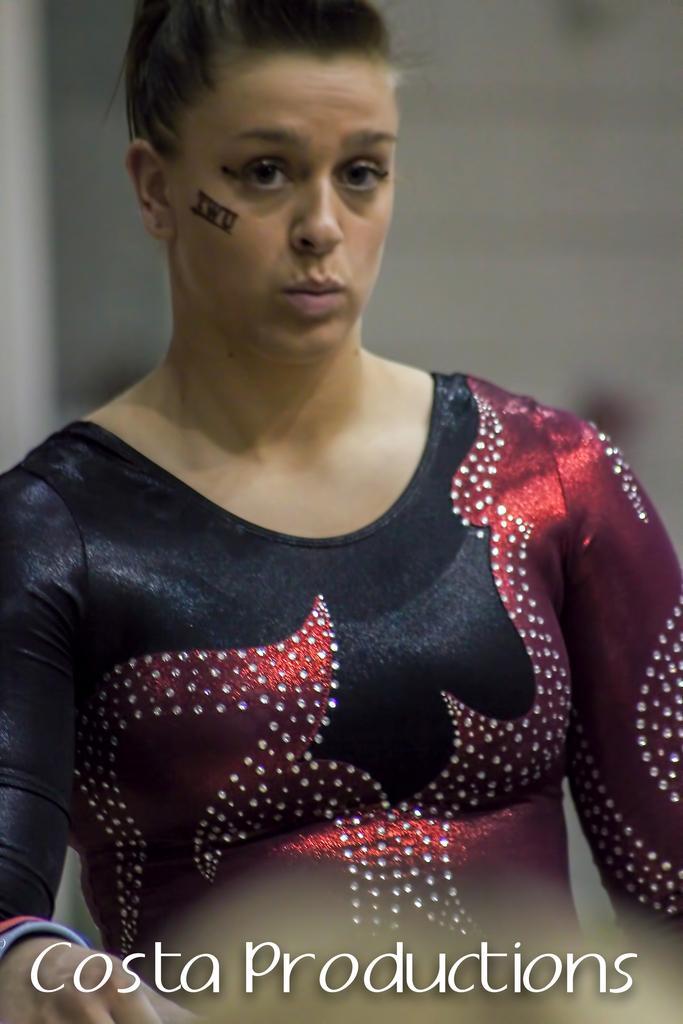Describe this image in one or two sentences. In this image, we can see a woman in black and maroon dress is seeing. Background there is a blur view. At the bottom of the image, we can see a watermark. 